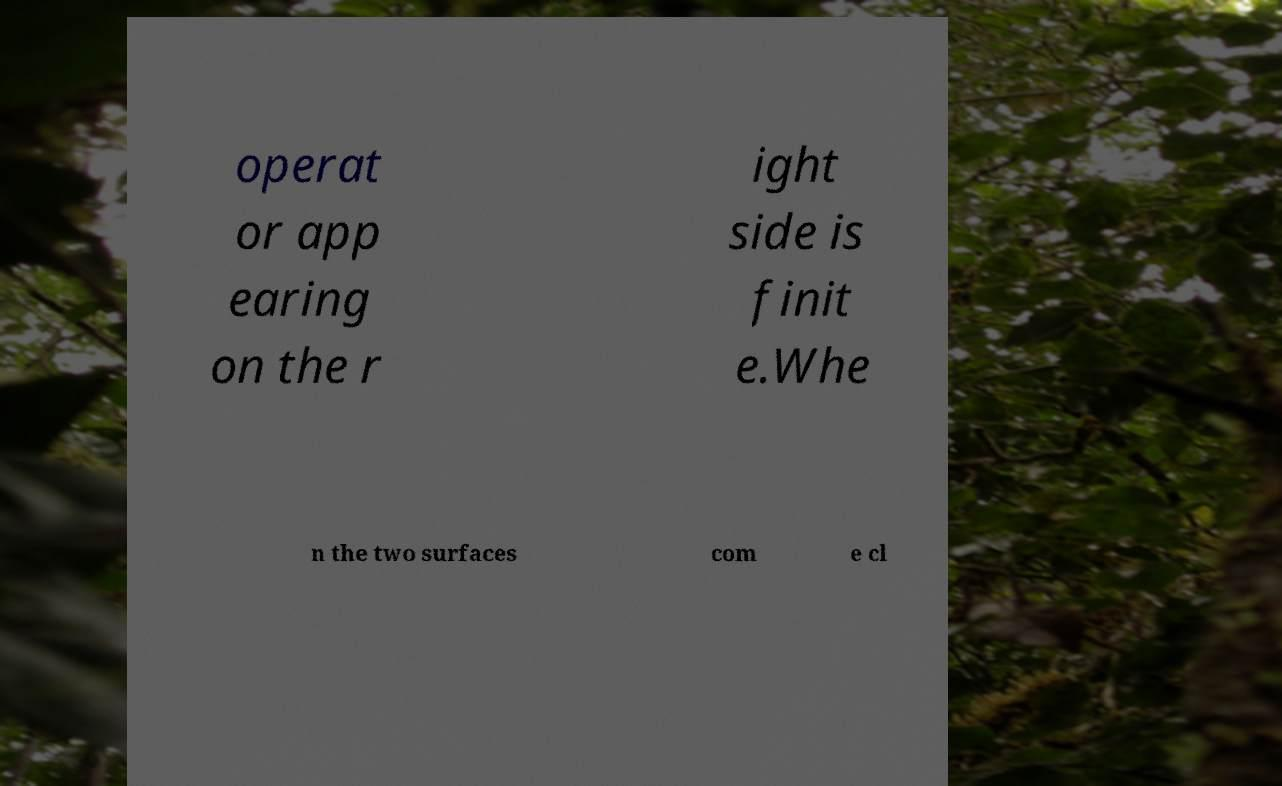What messages or text are displayed in this image? I need them in a readable, typed format. operat or app earing on the r ight side is finit e.Whe n the two surfaces com e cl 